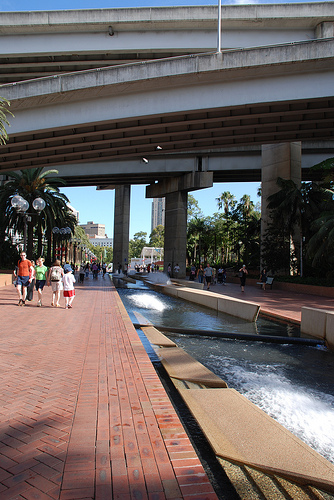<image>
Is there a water on the bridge? No. The water is not positioned on the bridge. They may be near each other, but the water is not supported by or resting on top of the bridge. Is the sidewalk in front of the boy? Yes. The sidewalk is positioned in front of the boy, appearing closer to the camera viewpoint. 